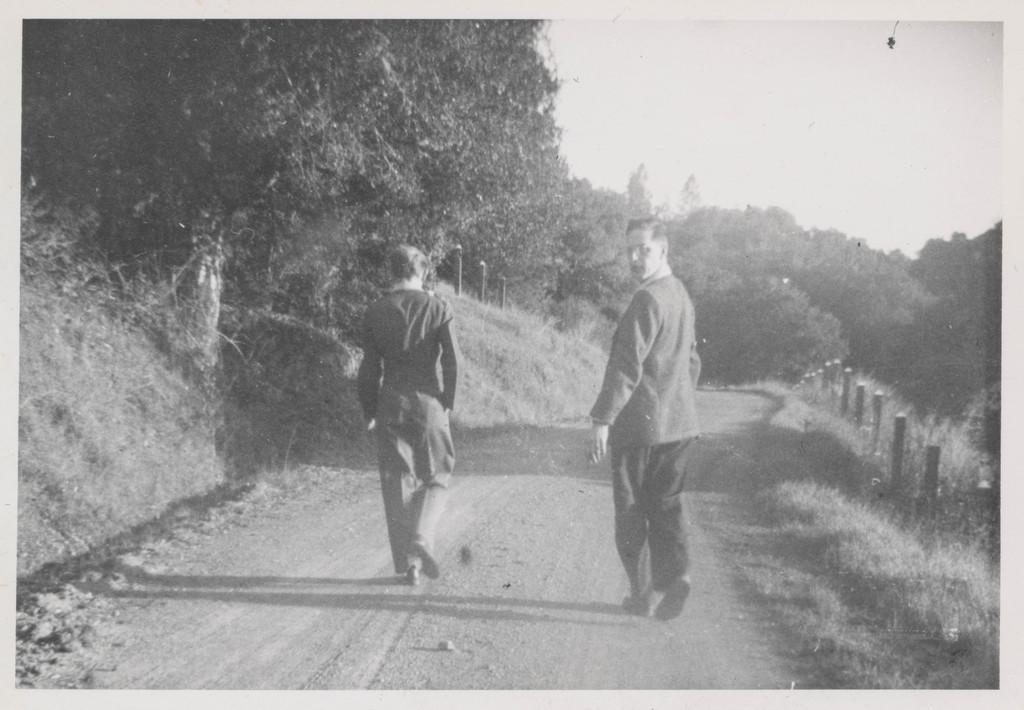In one or two sentences, can you explain what this image depicts? This is a black and white image, we can see there are two persons walking on the road in the middle of this image, and there are some trees in the background. There is a sky at the top of this image. 